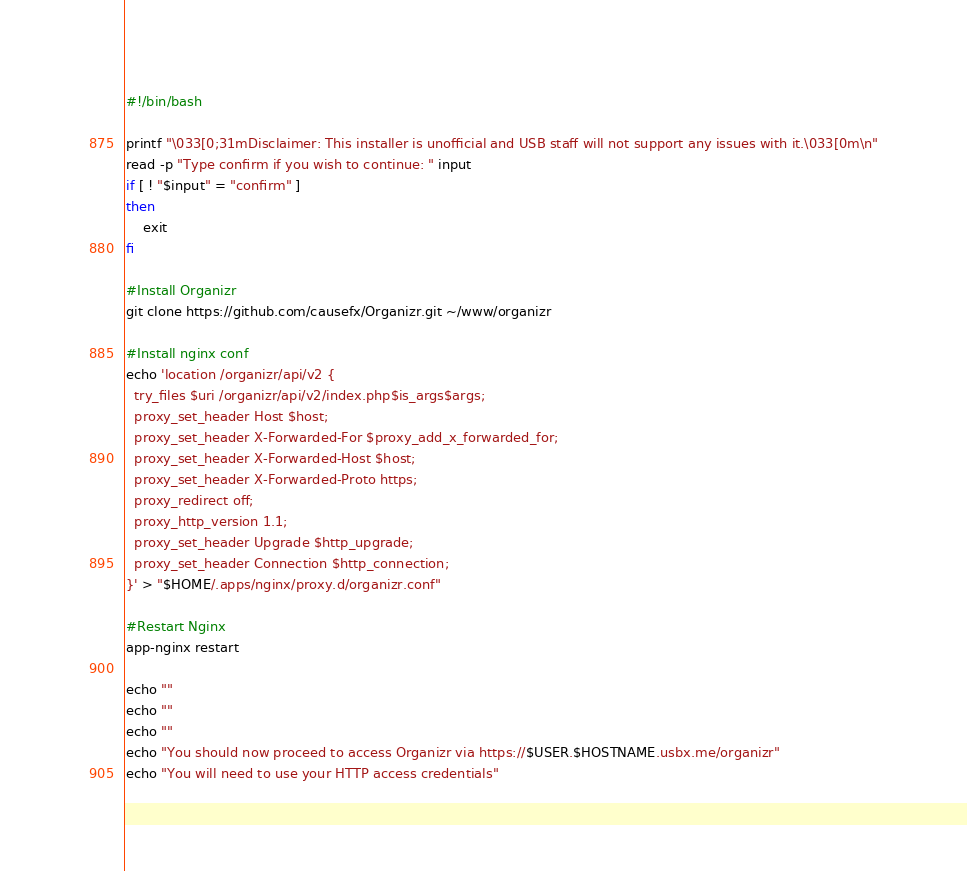Convert code to text. <code><loc_0><loc_0><loc_500><loc_500><_Bash_>#!/bin/bash

printf "\033[0;31mDisclaimer: This installer is unofficial and USB staff will not support any issues with it.\033[0m\n"
read -p "Type confirm if you wish to continue: " input
if [ ! "$input" = "confirm" ]
then
    exit
fi

#Install Organizr
git clone https://github.com/causefx/Organizr.git ~/www/organizr

#Install nginx conf
echo 'location /organizr/api/v2 {
  try_files $uri /organizr/api/v2/index.php$is_args$args;
  proxy_set_header Host $host;
  proxy_set_header X-Forwarded-For $proxy_add_x_forwarded_for;
  proxy_set_header X-Forwarded-Host $host;
  proxy_set_header X-Forwarded-Proto https;
  proxy_redirect off;
  proxy_http_version 1.1;
  proxy_set_header Upgrade $http_upgrade;
  proxy_set_header Connection $http_connection;
}' > "$HOME/.apps/nginx/proxy.d/organizr.conf"

#Restart Nginx
app-nginx restart

echo ""
echo ""
echo ""
echo "You should now proceed to access Organizr via https://$USER.$HOSTNAME.usbx.me/organizr"
echo "You will need to use your HTTP access credentials"
</code> 